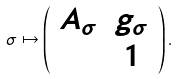<formula> <loc_0><loc_0><loc_500><loc_500>\sigma \mapsto \left ( \begin{array} { c c } A _ { \sigma } & g _ { \sigma } \\ & 1 \end{array} \right ) .</formula> 